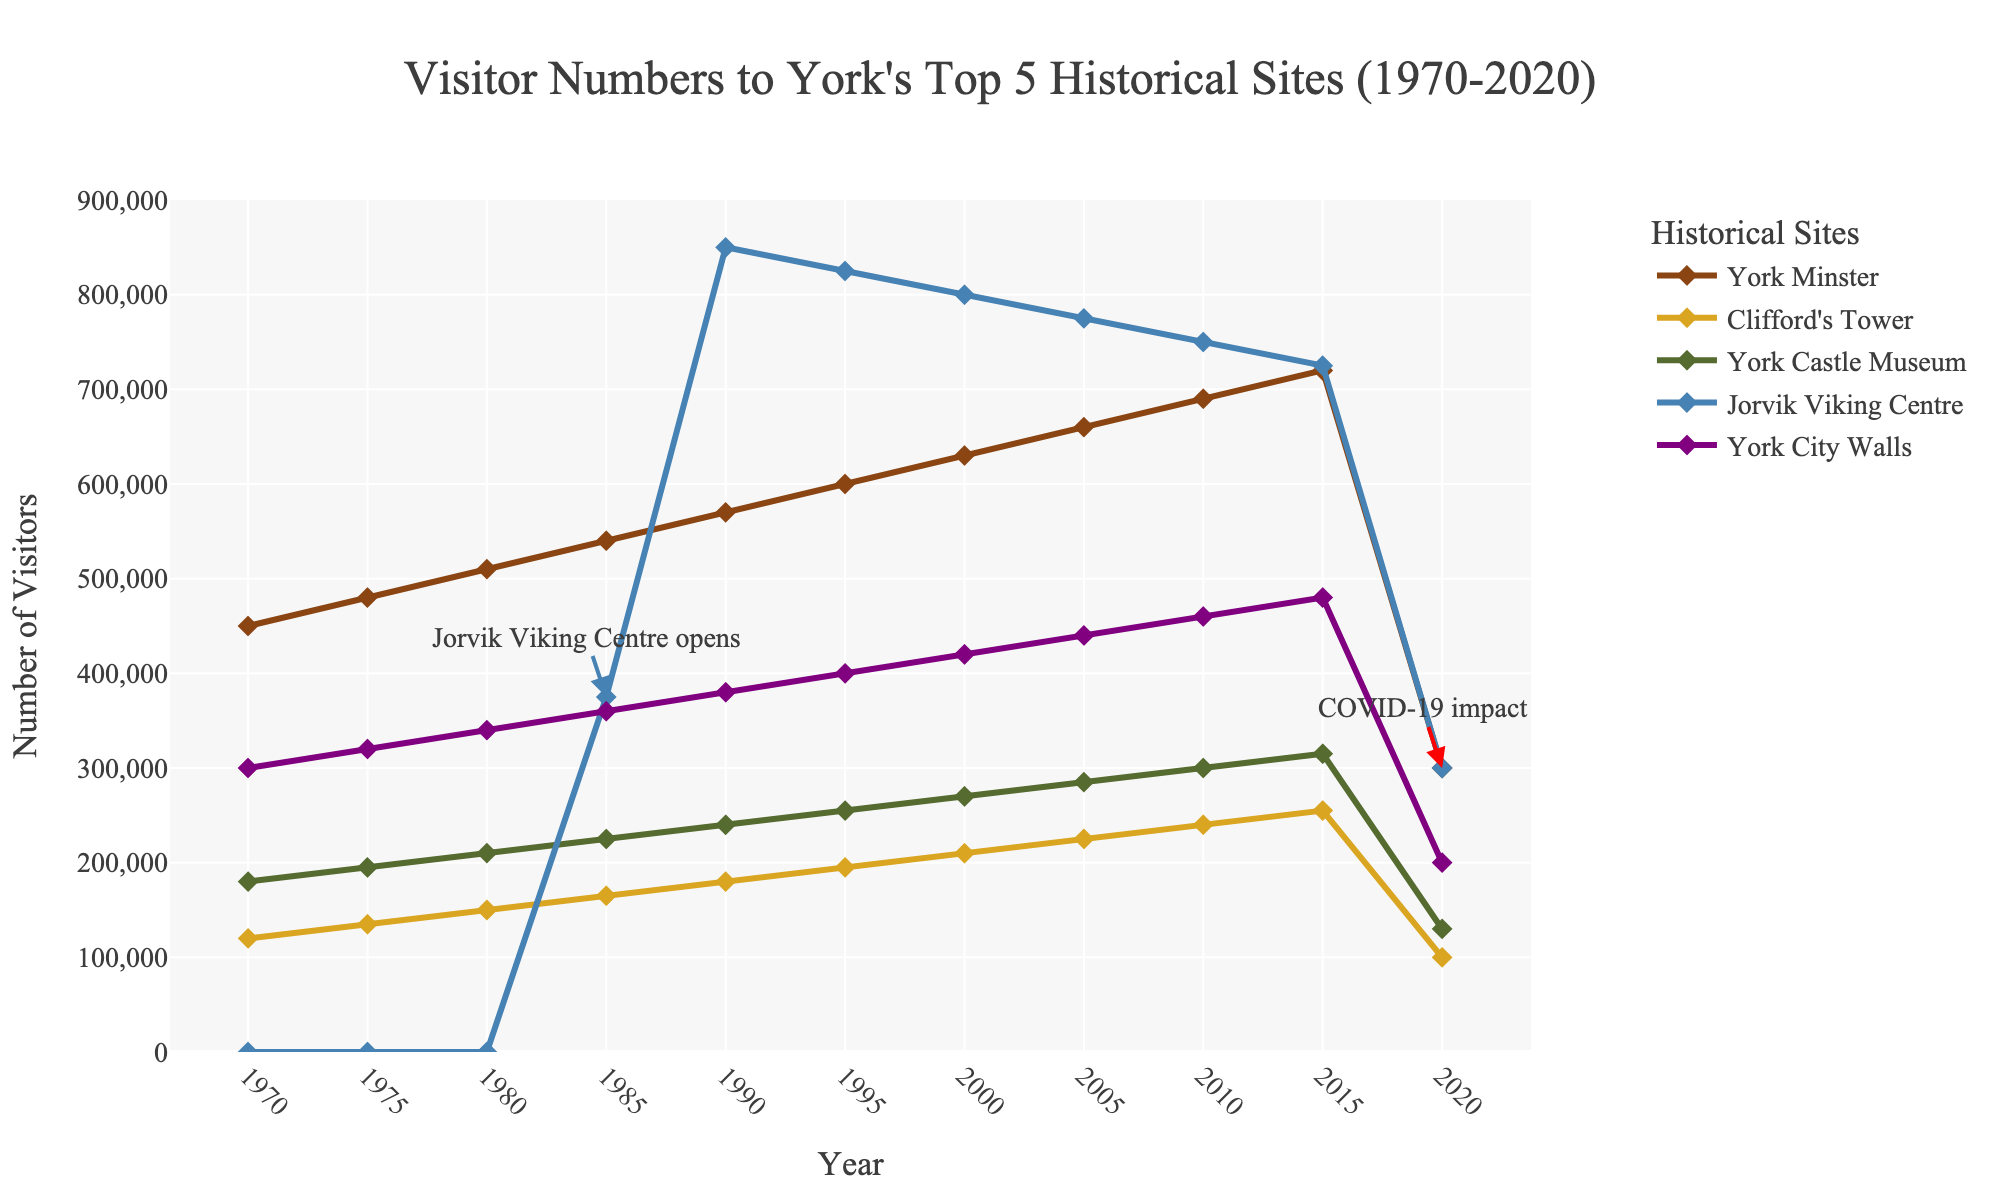What is the average number of visitors to York Minster from 1970 to 2020? To calculate the average, sum the visitor numbers for York Minster over the years 1970 to 2020: \(450000 + 480000 + 510000 + 540000 + 570000 + 600000 + 630000 + 660000 + 690000 + 720000 + 300000\). The sum is 6150000. There are 11 data points, so the average is \(6150000 / 11 \approx 559090.91\).
Answer: 559091 Which historical site had the most significant drop in visitor numbers between 2015 and 2020? Subtract the visitor numbers of each historical site in 2020 from the numbers in 2015 and compare the differences: York Minster (720000-300000=420000), Clifford's Tower (255000-100000=155000), York Castle Museum (315000-130000=185000), Jorvik Viking Centre (725000-300000=425000), York City Walls (480000-200000=280000). The largest decrease is for Jorvik Viking Centre with 425000 visitors.
Answer: Jorvik Viking Centre How many years did it take for the Jorvik Viking Centre to reach 800,000 visitors after its opening? Jorvik Viking Centre opened in 1985 and reached 800,000 visitors by 1990. The difference in years between 1985 and 1990 is \(1990 - 1985 = 5\).
Answer: 5 In what year did York Castle Museum first exceed 250,000 visitors? From the data, York Castle Museum exceeded 250,000 visitors in 1990 with 255,000 visitors.
Answer: 1990 Compare the trends of York Minster and York City Walls between 1970 and 2000. Which site had a more significant increase in visitors? Calculate the increase in visitors for each site: York Minster (2000 visitors - 1970 visitors = 630000 - 450000 = 180000), York City Walls (420000 - 300000 = 120000). York Minster had a more significant increase of 180000 visitors compared to York City Walls' 120000.
Answer: York Minster Which historical site consistently increased its visitor numbers from 1970 to 2020, except for the dip in 2020? Examine the trends for each site. York Minster shows a consistent increase from 450000 to 720000 from 1970 to 2015, except for the dip in 2020.
Answer: York Minster What is the total number of visitors to York Castle Museum in 1990 and Jorvik Viking Centre in 2000 combined? Add the visitor numbers of York Castle Museum in 1990 (240000) and Jorvik Viking Centre in 2000 (800000): \(240000 + 800000 = 1040000\).
Answer: 1040000 Which site had the least number of visitors in 2020 and by how much? Compare the visitor numbers in 2020: York Minster (300000), Clifford's Tower (100000), York Castle Museum (130000), Jorvik Viking Centre (300000), York City Walls (200000). Clifford's Tower had the least number of visitors. The difference between Clifford's Tower and the second least (York Castle Museum) is \(130000 - 100000 = 30000\).
Answer: Clifford's Tower, 30000 